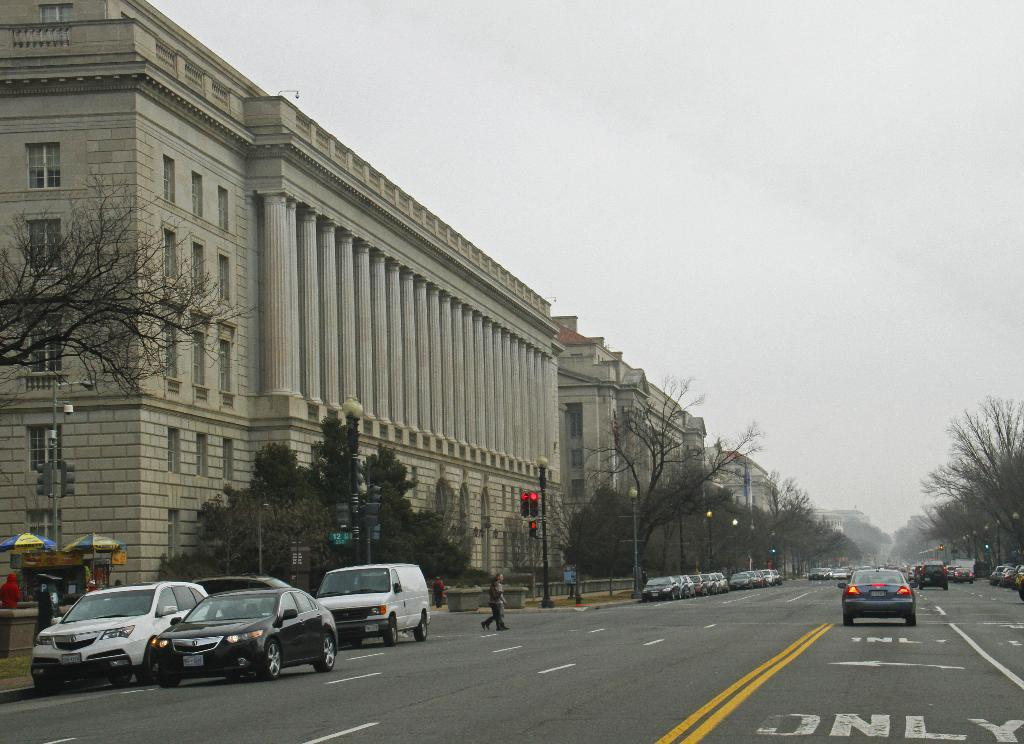What type of structures can be seen in the image? There are buildings in the image. What natural elements are present in the image? There are trees in the image. What type of traffic control devices are visible in the image? There are traffic signals in the image. What type of street furniture can be seen in the image? There are light poles in the image. What type of temporary shelters are present in the image? There are tents in the image. What type of transportation is visible in the image? There are vehicles in the image. What type of barrier is present in the image? There is fencing in the image. What type of vertical supports are visible in the image? There are poles in the image. Are there any human figures in the image? Yes, there are people in the image. What is the color of the sky in the image? The sky is white in color. Where is the lawyer's office located in the image? There is no mention of a lawyer or an office in the image. What type of fabric is used to make the linen in the image? There is no mention of linen in the image. 